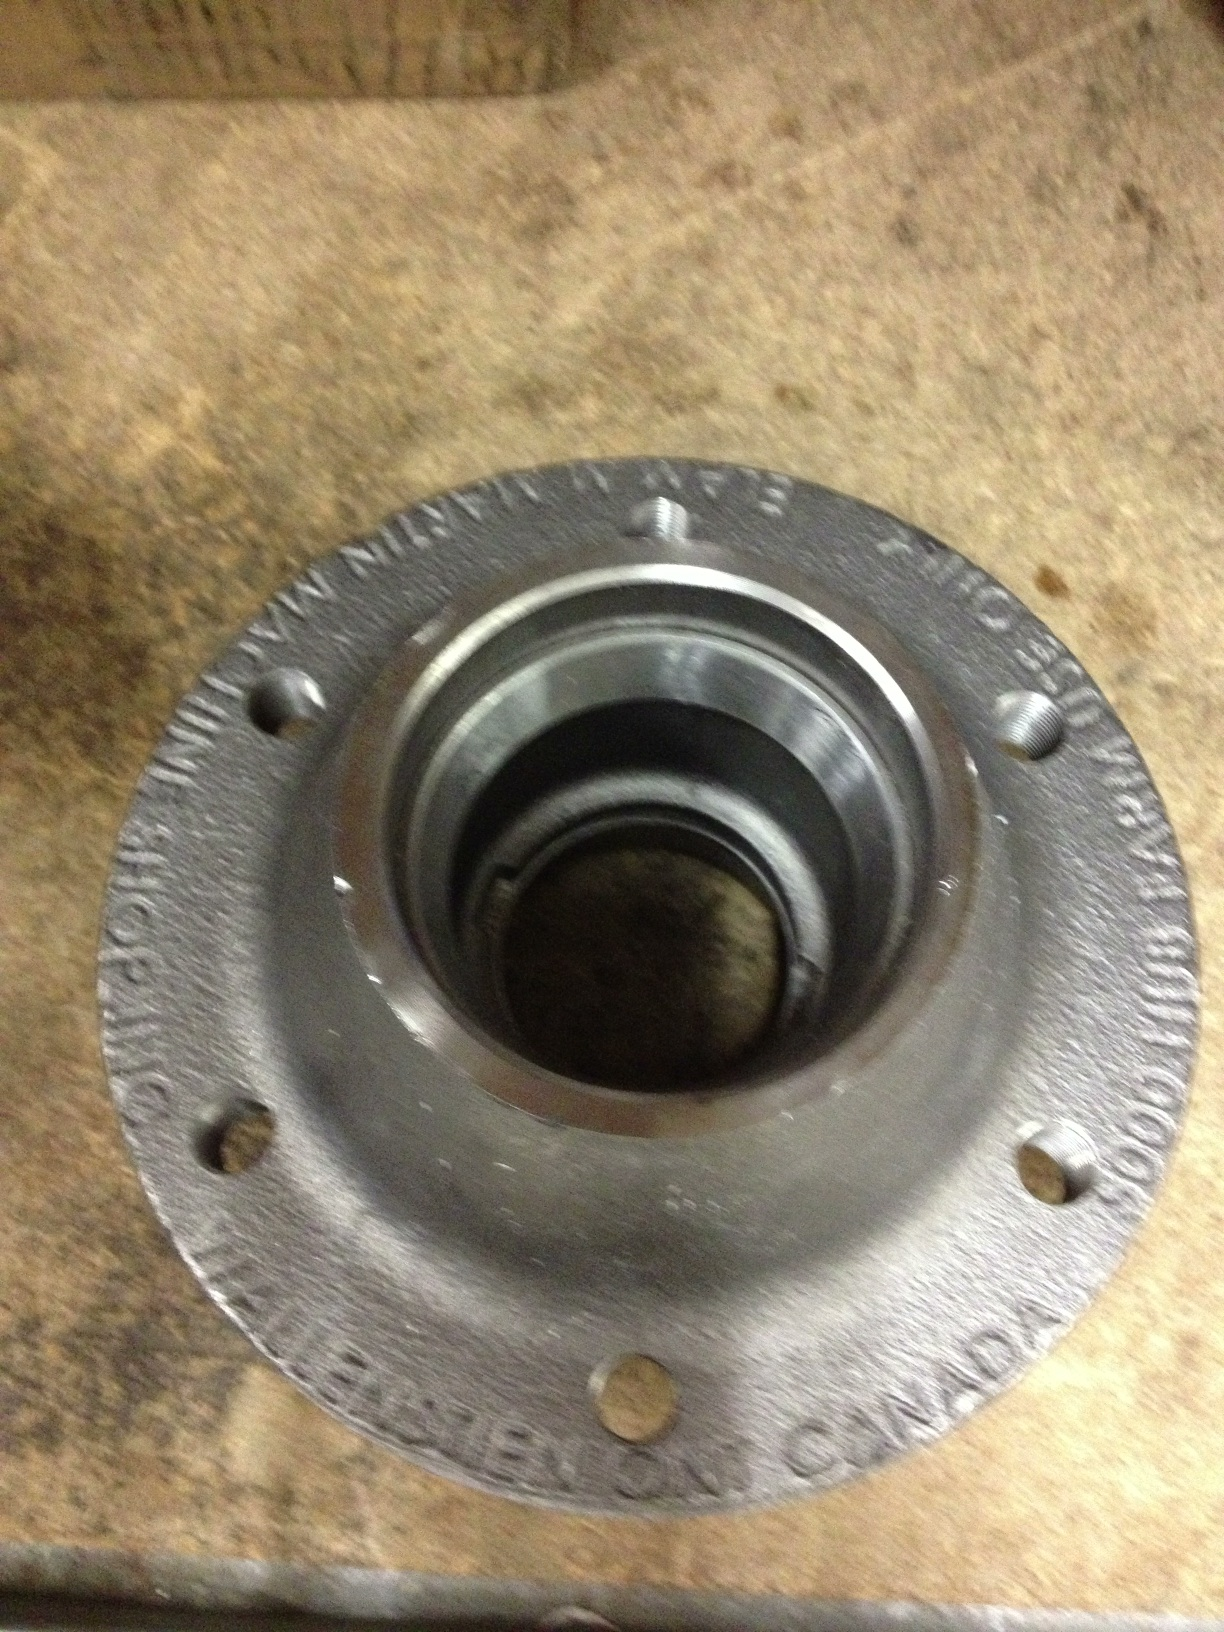How is this component used in a vehicle? In a vehicle, the wheel hub serves as the mounting assembly for the wheels. It is an essential part of the suspension system and allows the wheel to rotate while attached to the suspension. The wheel hub assembly contains the wheel bearings and hub units, enabling the wheel to turn freely and stay attached to the vehicle. Could you tell me more about the function of the bearings in the wheel hub? Certainly! The bearings in the wheel hub are designed to reduce friction between the hub and the axle, allowing the wheel to spin smoothly. These bearings support the vehicle’s weight and absorb the stresses from driving, improving the vehicle’s handling and efficiency. Properly functioning bearings are crucial for a safe and comfortable ride. If the bearings wear out or fail, it can lead to vibration, noise, and unsafe driving conditions. What might happen if the wheel hub fails? If the wheel hub fails, it can lead to several serious issues. The wheel may not be securely attached to the vehicle, which can cause it to wobble or even detach while driving. This can result in a loss of control and potentially cause an accident. Additionally, a failing wheel hub can damage other suspension components, leading to costly repairs. That’s why it is important to have wheel hubs inspected regularly and replaced when necessary to ensure they are in good working condition. What do you think happens inside a wheel hub during a high-speed race? During a high-speed race, the wheel hub experiences extreme forces and conditions. The bearings inside the hub must withstand intense friction and heat as the wheels spin at high velocities. Precision engineering and high-quality materials are essential to endure these conditions without failure. Any slight imperfection or wear can dramatically impact performance and safety in a high-speed scenario, emphasizing the importance of regular maintenance and using racing-grade components. 